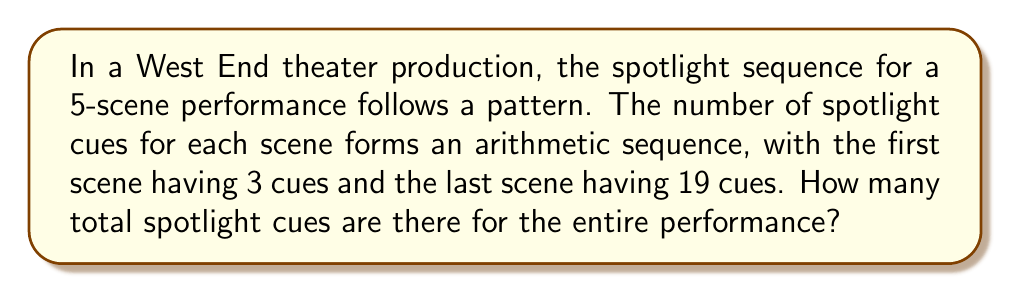Solve this math problem. Let's approach this step-by-step:

1) We know that the sequence is arithmetic, meaning the difference between each term is constant.

2) We have 5 scenes, so there are 5 terms in the sequence.

3) The first term $a_1 = 3$ and the last term $a_5 = 19$.

4) To find the common difference $d$, we can use the formula:
   $a_n = a_1 + (n-1)d$
   Where $n$ is the number of terms (5 in this case).

5) Substituting our known values:
   $19 = 3 + (5-1)d$
   $19 = 3 + 4d$
   $16 = 4d$
   $d = 4$

6) Now we know the sequence: 3, 7, 11, 15, 19

7) To find the sum of this arithmetic sequence, we can use the formula:
   $S_n = \frac{n}{2}(a_1 + a_n)$
   Where $S_n$ is the sum of $n$ terms.

8) Substituting our values:
   $S_5 = \frac{5}{2}(3 + 19)$
   $S_5 = \frac{5}{2}(22)$
   $S_5 = 55$

Therefore, there are 55 total spotlight cues for the entire performance.
Answer: 55 